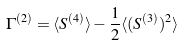Convert formula to latex. <formula><loc_0><loc_0><loc_500><loc_500>\Gamma ^ { ( 2 ) } = \langle S ^ { ( 4 ) } \rangle - \frac { 1 } { 2 } \langle ( S ^ { ( 3 ) } ) ^ { 2 } \rangle</formula> 